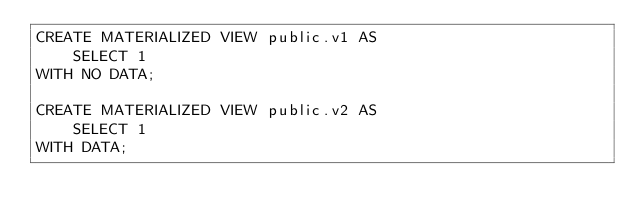Convert code to text. <code><loc_0><loc_0><loc_500><loc_500><_SQL_>CREATE MATERIALIZED VIEW public.v1 AS
    SELECT 1
WITH NO DATA;

CREATE MATERIALIZED VIEW public.v2 AS
    SELECT 1
WITH DATA;
</code> 